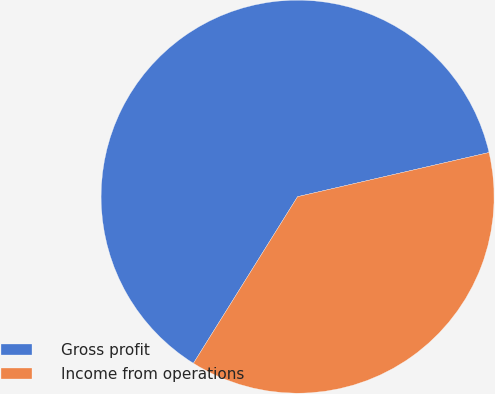Convert chart. <chart><loc_0><loc_0><loc_500><loc_500><pie_chart><fcel>Gross profit<fcel>Income from operations<nl><fcel>62.5%<fcel>37.5%<nl></chart> 